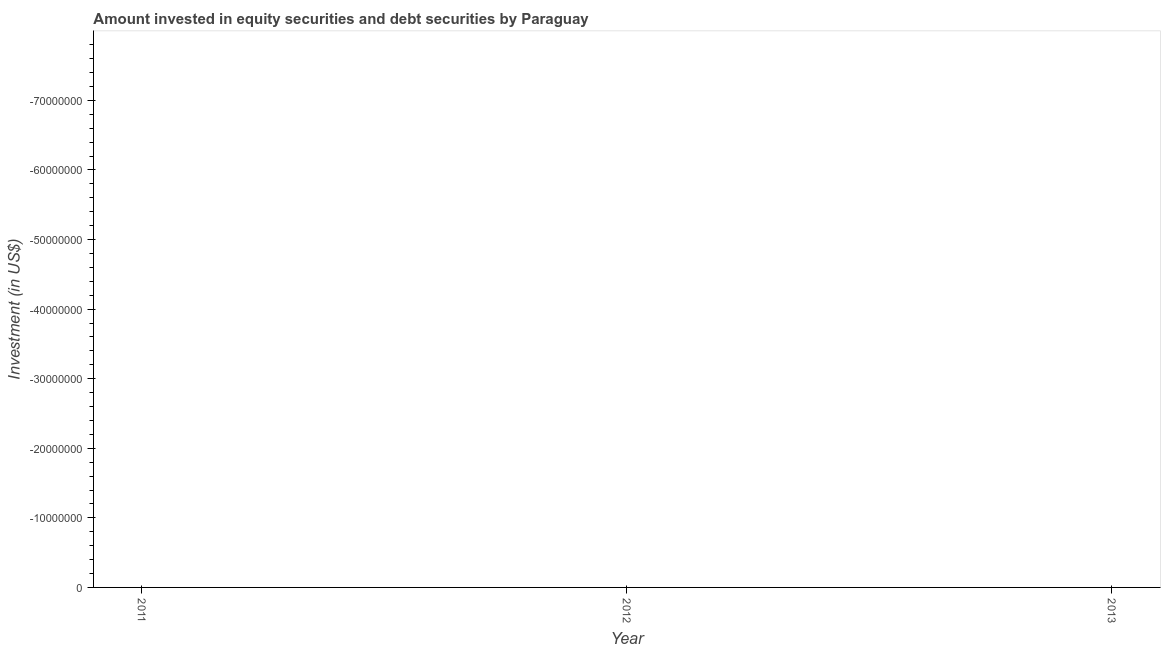What is the portfolio investment in 2012?
Offer a very short reply. 0. Across all years, what is the minimum portfolio investment?
Your answer should be compact. 0. What is the median portfolio investment?
Ensure brevity in your answer.  0. How many lines are there?
Your answer should be compact. 0. Are the values on the major ticks of Y-axis written in scientific E-notation?
Provide a succinct answer. No. What is the title of the graph?
Your answer should be compact. Amount invested in equity securities and debt securities by Paraguay. What is the label or title of the X-axis?
Ensure brevity in your answer.  Year. What is the label or title of the Y-axis?
Your answer should be compact. Investment (in US$). What is the Investment (in US$) in 2012?
Your answer should be very brief. 0. 